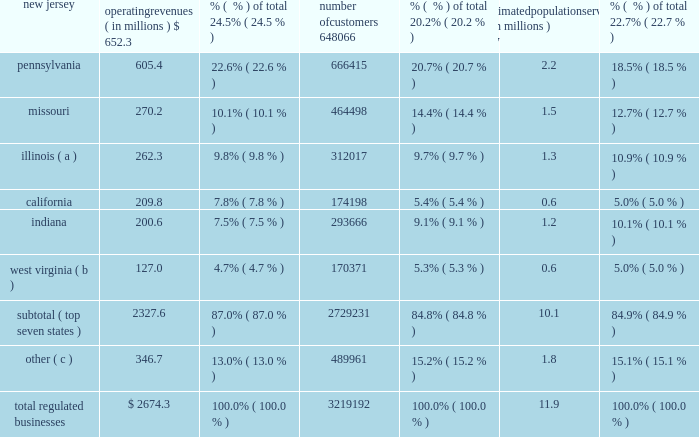Part i item 1 .
Business our company founded in 1886 , american water works company , inc. , ( the 201ccompany , 201d 201camerican water 201d or 201caww 201d ) is a delaware holding company .
American water is the most geographically diversified , as well as the largest publicly-traded , united states water and wastewater utility company , as measured by both operating revenues and population served .
As a holding company , we conduct substantially all of our business operations through our subsidiaries .
Our approximately 6400 employees provide an estimated 15 million people with drinking water , wastewater and/or other water-related services in 47 states and one canadian province .
Operating segments we report our results of operations in two operating segments : the regulated businesses and the market- based operations .
Additional information with respect to our operating segment results is included in the section entitled 201citem 7 2014management 2019s discussion and analysis of financial condition and results of operations , 201d and note 18 of the consolidated financial statements .
Regulated businesses our primary business involves the ownership of subsidiaries that provide water and wastewater utility services to residential , commercial , industrial and other customers , including sale for resale and public authority customers .
We report the results of this business in our regulated businesses segment .
Our subsidiaries that provide these services are generally subject to economic regulation by certain state commissions or other entities engaged in economic regulation , hereafter referred to as public utility commissions , or 201cpucs , 201d of the states in which we operate .
The federal and state governments also regulate environmental , health and safety , and water quality matters .
Our regulated businesses segment operating revenues were $ 2674.3 million for 2014 , $ 2539.9 for 2013 , $ 2564.4 million for 2012 , accounting for 88.8% ( 88.8 % ) , 90.1% ( 90.1 % ) and 89.9% ( 89.9 % ) , respectively , of total operating revenues for the same periods .
The table sets forth our regulated businesses operating revenues , number of customers and an estimate of population served as of december 31 , 2014 : operating revenues ( in millions ) % (  % ) of total number of customers % (  % ) of total estimated population served ( in millions ) % (  % ) of total .
( a ) includes illinois-american water company , which we refer to as ilawc and american lake water company , also a regulated subsidiary in illinois. .
What is the approximate customer penetration in the pennsylvania market area? 
Computations: (666415 / (2.2 * 1000000))
Answer: 0.30292. 